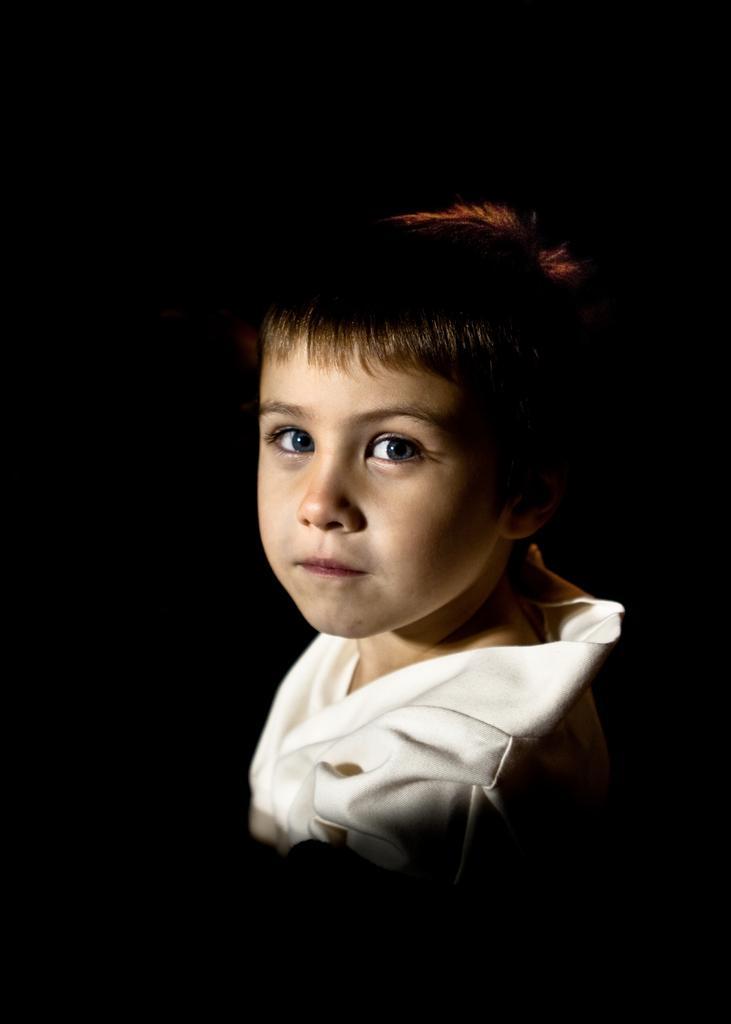Could you give a brief overview of what you see in this image? In the center of the image we can see a child. 